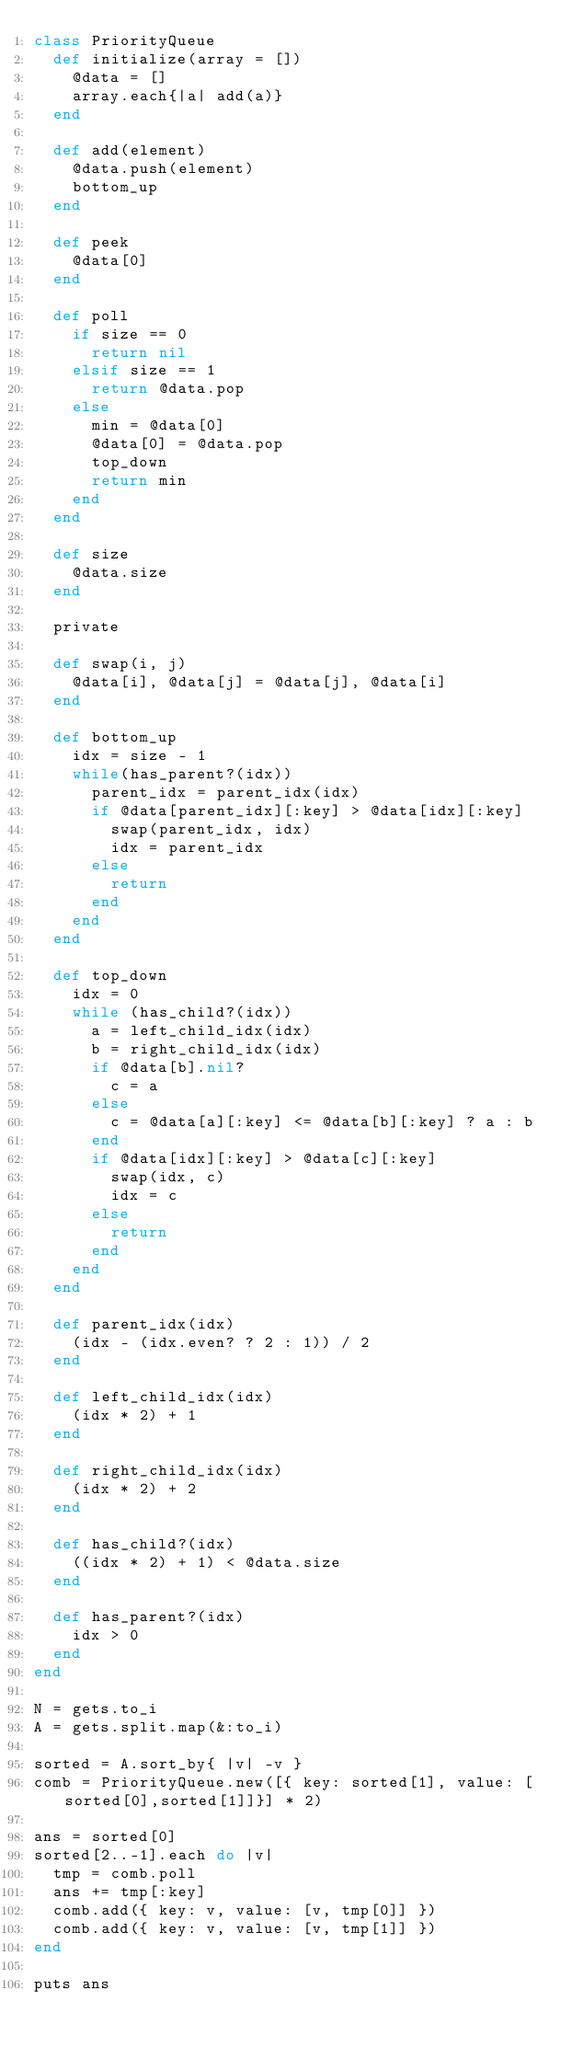<code> <loc_0><loc_0><loc_500><loc_500><_Ruby_>class PriorityQueue
  def initialize(array = [])
    @data = []
    array.each{|a| add(a)}
  end

  def add(element)
    @data.push(element)
    bottom_up
  end

  def peek
    @data[0]
  end

  def poll
    if size == 0
      return nil
    elsif size == 1
      return @data.pop
    else
      min = @data[0]
      @data[0] = @data.pop
      top_down
      return min
    end
  end

  def size
    @data.size
  end

  private

  def swap(i, j)
    @data[i], @data[j] = @data[j], @data[i]
  end

  def bottom_up
    idx = size - 1
    while(has_parent?(idx))
      parent_idx = parent_idx(idx)
      if @data[parent_idx][:key] > @data[idx][:key]
        swap(parent_idx, idx)
        idx = parent_idx
      else
        return
      end
    end
  end

  def top_down
    idx = 0
    while (has_child?(idx))
      a = left_child_idx(idx)
      b = right_child_idx(idx)
      if @data[b].nil?
        c = a
      else
        c = @data[a][:key] <= @data[b][:key] ? a : b
      end
      if @data[idx][:key] > @data[c][:key]
        swap(idx, c)
        idx = c
      else
        return
      end
    end
  end

  def parent_idx(idx)
    (idx - (idx.even? ? 2 : 1)) / 2
  end

  def left_child_idx(idx)
    (idx * 2) + 1
  end

  def right_child_idx(idx)
    (idx * 2) + 2
  end

  def has_child?(idx)
    ((idx * 2) + 1) < @data.size
  end

  def has_parent?(idx)
    idx > 0
  end
end

N = gets.to_i
A = gets.split.map(&:to_i)

sorted = A.sort_by{ |v| -v }
comb = PriorityQueue.new([{ key: sorted[1], value: [sorted[0],sorted[1]]}] * 2)

ans = sorted[0]
sorted[2..-1].each do |v|
  tmp = comb.poll
  ans += tmp[:key]
  comb.add({ key: v, value: [v, tmp[0]] })
  comb.add({ key: v, value: [v, tmp[1]] })
end

puts ans
</code> 